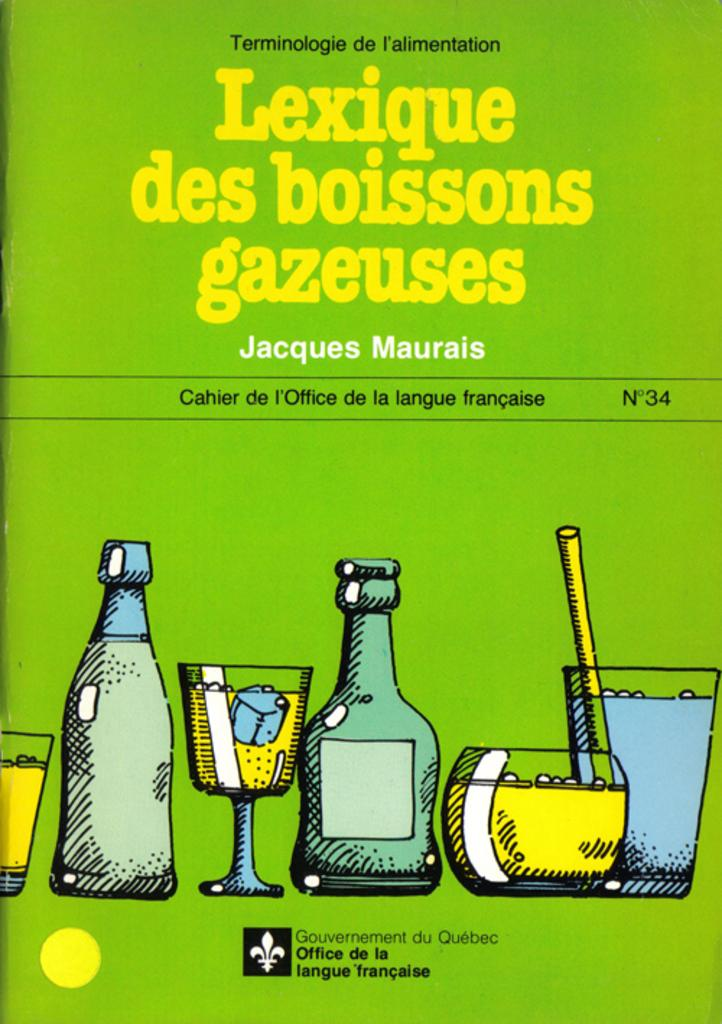<image>
Create a compact narrative representing the image presented. The Lexique des boissons gazeuses book shows images of drinks on the front cover. 